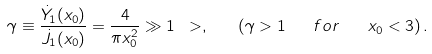<formula> <loc_0><loc_0><loc_500><loc_500>\gamma \equiv \frac { \dot { Y } _ { 1 } ( x _ { 0 } ) } { \dot { J } _ { 1 } ( x _ { 0 } ) } = \frac { 4 } { \pi x _ { 0 } ^ { 2 } } \gg 1 \ > , \quad ( \gamma > 1 \quad f o r \quad x _ { 0 } < 3 ) \, .</formula> 